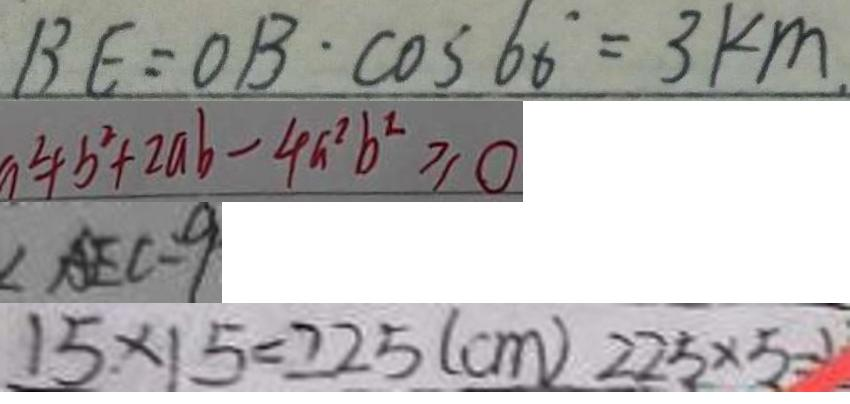<formula> <loc_0><loc_0><loc_500><loc_500>B E = O B \cdot \cos 6 0 ^ { \circ } = 3 k m . 
 a ^ { 2 } + b ^ { 2 } + 2 a b - 4 a ^ { 2 } b ^ { 2 } \geq 0 
 \angle A E C = 9 
 1 5 \times 1 5 = 2 2 5 ( c m ) 2 2 5 \times 5</formula> 